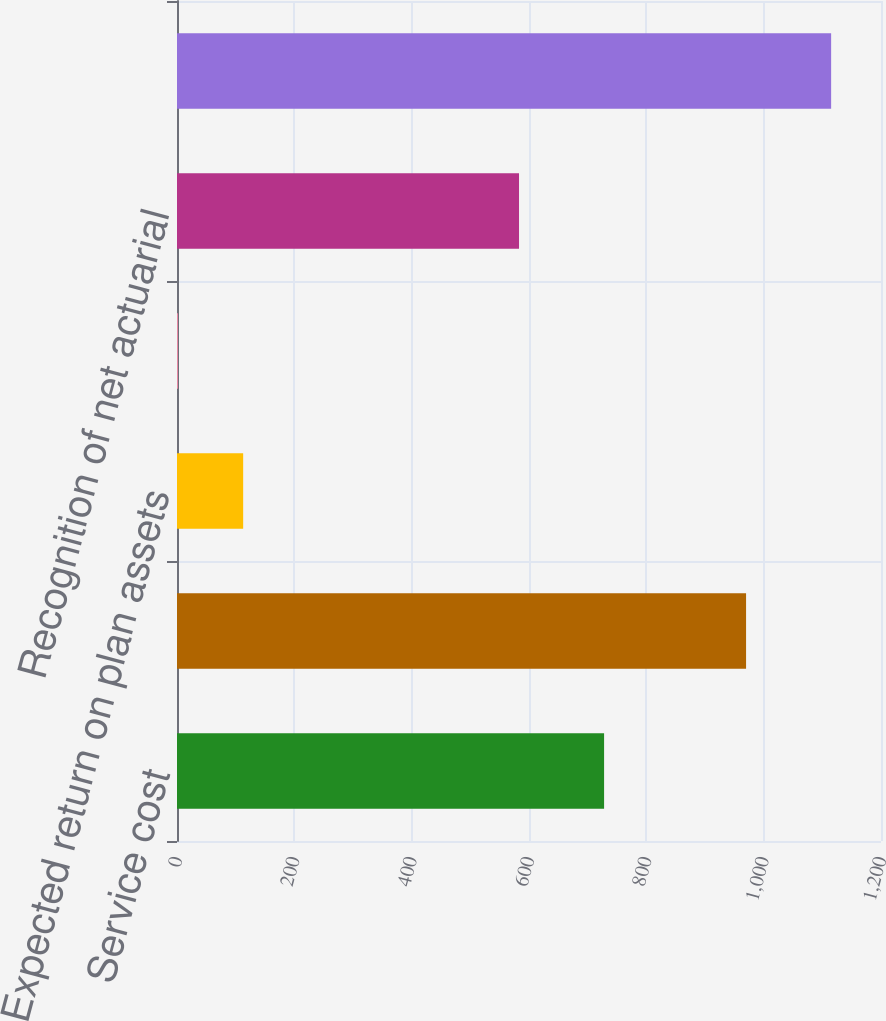Convert chart to OTSL. <chart><loc_0><loc_0><loc_500><loc_500><bar_chart><fcel>Service cost<fcel>Interest cost on benefit<fcel>Expected return on plan assets<fcel>Amortization of prior service<fcel>Recognition of net actuarial<fcel>Net periodic postretirement<nl><fcel>728<fcel>970<fcel>112.79<fcel>1.43<fcel>583<fcel>1115<nl></chart> 